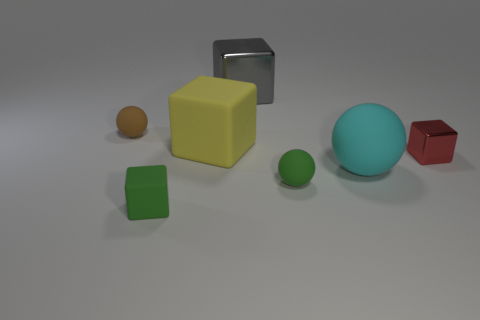There is a gray thing; is its size the same as the rubber block that is behind the red thing?
Your answer should be compact. Yes. There is a tiny object that is behind the large cyan object and to the right of the large yellow rubber object; what is its shape?
Ensure brevity in your answer.  Cube. What number of tiny things are spheres or blocks?
Provide a short and direct response. 4. Is the number of objects that are to the right of the yellow block the same as the number of matte objects in front of the brown thing?
Offer a very short reply. Yes. How many other things are the same color as the large sphere?
Ensure brevity in your answer.  0. Is the number of big yellow matte blocks behind the big rubber cube the same as the number of red balls?
Keep it short and to the point. Yes. Do the cyan ball and the yellow matte thing have the same size?
Your answer should be compact. Yes. The object that is both left of the large yellow object and in front of the large yellow rubber cube is made of what material?
Your answer should be very brief. Rubber. What number of green matte things are the same shape as the red metallic thing?
Offer a very short reply. 1. There is a thing that is behind the brown ball; what material is it?
Give a very brief answer. Metal. 